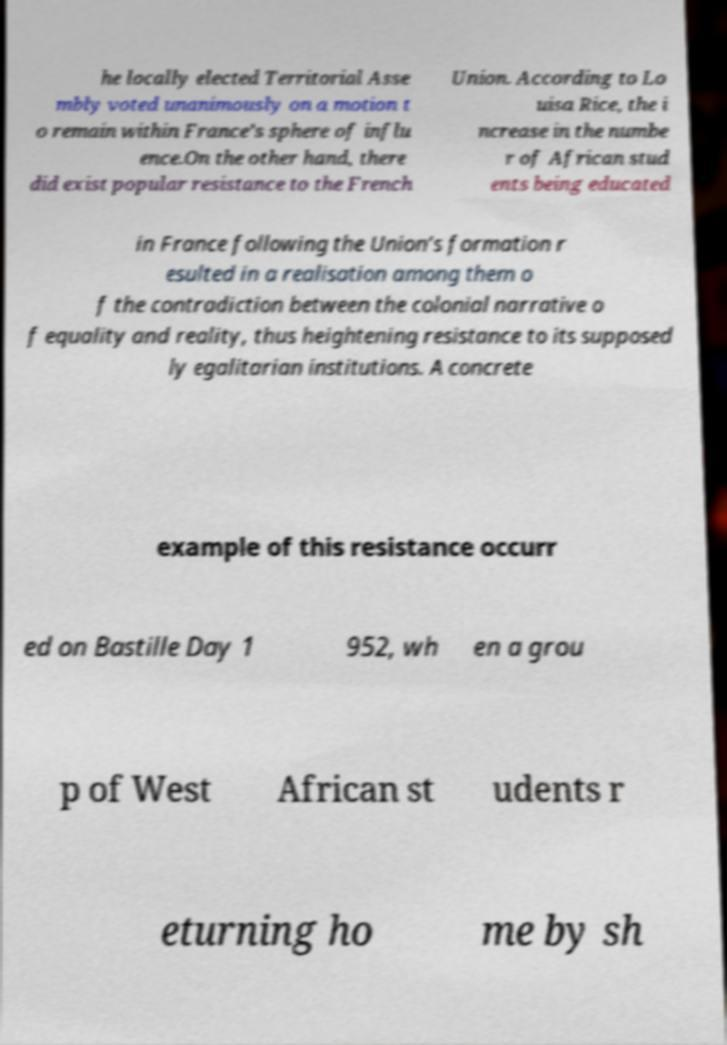For documentation purposes, I need the text within this image transcribed. Could you provide that? he locally elected Territorial Asse mbly voted unanimously on a motion t o remain within France’s sphere of influ ence.On the other hand, there did exist popular resistance to the French Union. According to Lo uisa Rice, the i ncrease in the numbe r of African stud ents being educated in France following the Union’s formation r esulted in a realisation among them o f the contradiction between the colonial narrative o f equality and reality, thus heightening resistance to its supposed ly egalitarian institutions. A concrete example of this resistance occurr ed on Bastille Day 1 952, wh en a grou p of West African st udents r eturning ho me by sh 